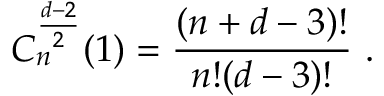Convert formula to latex. <formula><loc_0><loc_0><loc_500><loc_500>C _ { n } ^ { \frac { d - 2 } 2 } ( 1 ) = \frac { ( n + d - 3 ) ! } { n ! ( d - 3 ) ! } \ .</formula> 